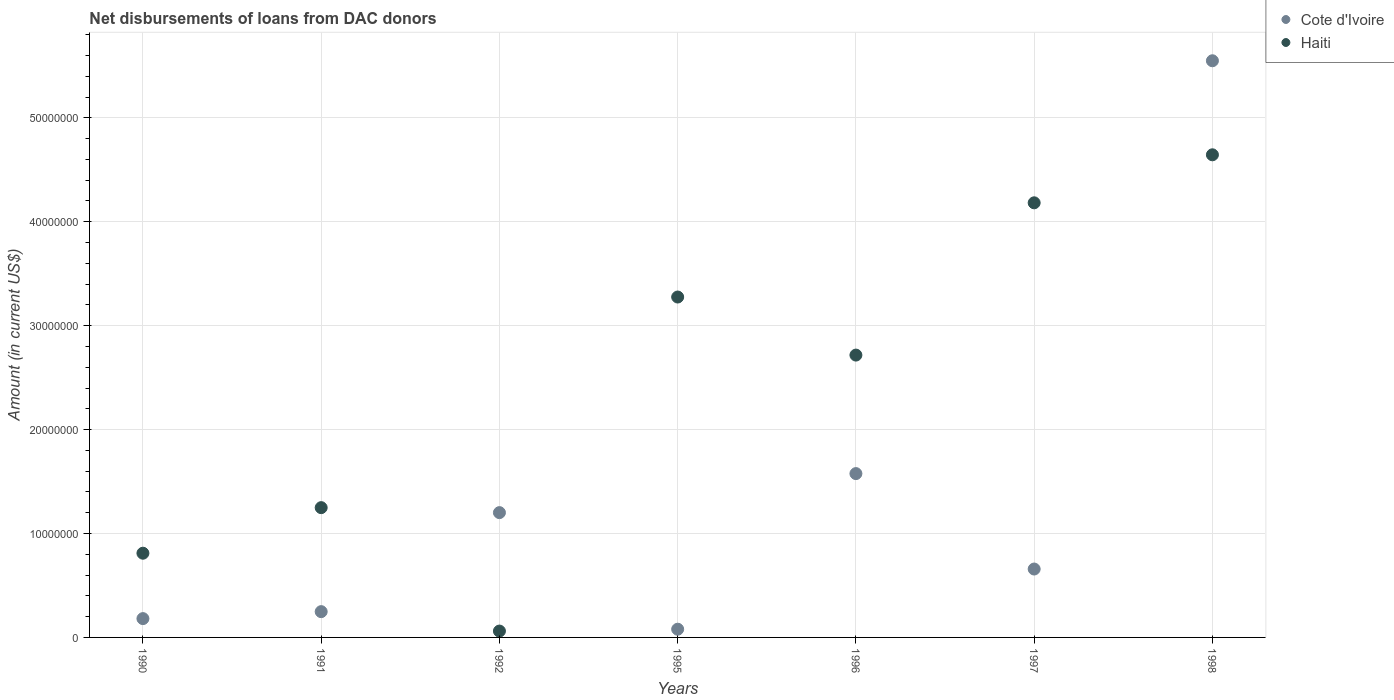How many different coloured dotlines are there?
Provide a succinct answer. 2. Is the number of dotlines equal to the number of legend labels?
Ensure brevity in your answer.  Yes. What is the amount of loans disbursed in Cote d'Ivoire in 1998?
Provide a short and direct response. 5.55e+07. Across all years, what is the maximum amount of loans disbursed in Haiti?
Offer a terse response. 4.64e+07. Across all years, what is the minimum amount of loans disbursed in Haiti?
Your answer should be very brief. 6.12e+05. What is the total amount of loans disbursed in Haiti in the graph?
Your response must be concise. 1.69e+08. What is the difference between the amount of loans disbursed in Cote d'Ivoire in 1995 and that in 1997?
Offer a very short reply. -5.79e+06. What is the difference between the amount of loans disbursed in Haiti in 1995 and the amount of loans disbursed in Cote d'Ivoire in 1997?
Offer a very short reply. 2.62e+07. What is the average amount of loans disbursed in Haiti per year?
Your answer should be very brief. 2.42e+07. In the year 1992, what is the difference between the amount of loans disbursed in Cote d'Ivoire and amount of loans disbursed in Haiti?
Your answer should be compact. 1.14e+07. In how many years, is the amount of loans disbursed in Haiti greater than 24000000 US$?
Keep it short and to the point. 4. What is the ratio of the amount of loans disbursed in Haiti in 1991 to that in 1997?
Provide a succinct answer. 0.3. Is the difference between the amount of loans disbursed in Cote d'Ivoire in 1995 and 1996 greater than the difference between the amount of loans disbursed in Haiti in 1995 and 1996?
Your response must be concise. No. What is the difference between the highest and the second highest amount of loans disbursed in Cote d'Ivoire?
Make the answer very short. 3.97e+07. What is the difference between the highest and the lowest amount of loans disbursed in Haiti?
Offer a terse response. 4.58e+07. In how many years, is the amount of loans disbursed in Haiti greater than the average amount of loans disbursed in Haiti taken over all years?
Provide a short and direct response. 4. Does the amount of loans disbursed in Cote d'Ivoire monotonically increase over the years?
Your answer should be very brief. No. Is the amount of loans disbursed in Cote d'Ivoire strictly greater than the amount of loans disbursed in Haiti over the years?
Keep it short and to the point. No. Is the amount of loans disbursed in Haiti strictly less than the amount of loans disbursed in Cote d'Ivoire over the years?
Your response must be concise. No. What is the difference between two consecutive major ticks on the Y-axis?
Keep it short and to the point. 1.00e+07. Does the graph contain grids?
Your response must be concise. Yes. What is the title of the graph?
Your answer should be compact. Net disbursements of loans from DAC donors. Does "Australia" appear as one of the legend labels in the graph?
Offer a very short reply. No. What is the label or title of the Y-axis?
Provide a succinct answer. Amount (in current US$). What is the Amount (in current US$) in Cote d'Ivoire in 1990?
Give a very brief answer. 1.81e+06. What is the Amount (in current US$) in Haiti in 1990?
Your response must be concise. 8.10e+06. What is the Amount (in current US$) of Cote d'Ivoire in 1991?
Make the answer very short. 2.48e+06. What is the Amount (in current US$) of Haiti in 1991?
Keep it short and to the point. 1.25e+07. What is the Amount (in current US$) in Cote d'Ivoire in 1992?
Your answer should be very brief. 1.20e+07. What is the Amount (in current US$) of Haiti in 1992?
Offer a very short reply. 6.12e+05. What is the Amount (in current US$) in Cote d'Ivoire in 1995?
Offer a terse response. 7.91e+05. What is the Amount (in current US$) of Haiti in 1995?
Your answer should be very brief. 3.28e+07. What is the Amount (in current US$) of Cote d'Ivoire in 1996?
Ensure brevity in your answer.  1.58e+07. What is the Amount (in current US$) in Haiti in 1996?
Offer a terse response. 2.72e+07. What is the Amount (in current US$) of Cote d'Ivoire in 1997?
Ensure brevity in your answer.  6.58e+06. What is the Amount (in current US$) of Haiti in 1997?
Provide a short and direct response. 4.18e+07. What is the Amount (in current US$) in Cote d'Ivoire in 1998?
Your answer should be compact. 5.55e+07. What is the Amount (in current US$) in Haiti in 1998?
Provide a short and direct response. 4.64e+07. Across all years, what is the maximum Amount (in current US$) in Cote d'Ivoire?
Keep it short and to the point. 5.55e+07. Across all years, what is the maximum Amount (in current US$) of Haiti?
Your response must be concise. 4.64e+07. Across all years, what is the minimum Amount (in current US$) of Cote d'Ivoire?
Your response must be concise. 7.91e+05. Across all years, what is the minimum Amount (in current US$) of Haiti?
Provide a short and direct response. 6.12e+05. What is the total Amount (in current US$) in Cote d'Ivoire in the graph?
Offer a very short reply. 9.49e+07. What is the total Amount (in current US$) of Haiti in the graph?
Ensure brevity in your answer.  1.69e+08. What is the difference between the Amount (in current US$) of Cote d'Ivoire in 1990 and that in 1991?
Ensure brevity in your answer.  -6.70e+05. What is the difference between the Amount (in current US$) in Haiti in 1990 and that in 1991?
Provide a short and direct response. -4.38e+06. What is the difference between the Amount (in current US$) in Cote d'Ivoire in 1990 and that in 1992?
Offer a terse response. -1.02e+07. What is the difference between the Amount (in current US$) in Haiti in 1990 and that in 1992?
Provide a short and direct response. 7.49e+06. What is the difference between the Amount (in current US$) of Cote d'Ivoire in 1990 and that in 1995?
Your response must be concise. 1.02e+06. What is the difference between the Amount (in current US$) of Haiti in 1990 and that in 1995?
Give a very brief answer. -2.47e+07. What is the difference between the Amount (in current US$) in Cote d'Ivoire in 1990 and that in 1996?
Offer a very short reply. -1.40e+07. What is the difference between the Amount (in current US$) in Haiti in 1990 and that in 1996?
Offer a very short reply. -1.91e+07. What is the difference between the Amount (in current US$) in Cote d'Ivoire in 1990 and that in 1997?
Offer a terse response. -4.77e+06. What is the difference between the Amount (in current US$) in Haiti in 1990 and that in 1997?
Ensure brevity in your answer.  -3.37e+07. What is the difference between the Amount (in current US$) in Cote d'Ivoire in 1990 and that in 1998?
Give a very brief answer. -5.37e+07. What is the difference between the Amount (in current US$) in Haiti in 1990 and that in 1998?
Offer a terse response. -3.83e+07. What is the difference between the Amount (in current US$) of Cote d'Ivoire in 1991 and that in 1992?
Your answer should be compact. -9.53e+06. What is the difference between the Amount (in current US$) in Haiti in 1991 and that in 1992?
Provide a succinct answer. 1.19e+07. What is the difference between the Amount (in current US$) of Cote d'Ivoire in 1991 and that in 1995?
Provide a short and direct response. 1.69e+06. What is the difference between the Amount (in current US$) in Haiti in 1991 and that in 1995?
Your answer should be very brief. -2.03e+07. What is the difference between the Amount (in current US$) of Cote d'Ivoire in 1991 and that in 1996?
Ensure brevity in your answer.  -1.33e+07. What is the difference between the Amount (in current US$) of Haiti in 1991 and that in 1996?
Your response must be concise. -1.47e+07. What is the difference between the Amount (in current US$) of Cote d'Ivoire in 1991 and that in 1997?
Offer a very short reply. -4.10e+06. What is the difference between the Amount (in current US$) in Haiti in 1991 and that in 1997?
Make the answer very short. -2.93e+07. What is the difference between the Amount (in current US$) of Cote d'Ivoire in 1991 and that in 1998?
Ensure brevity in your answer.  -5.30e+07. What is the difference between the Amount (in current US$) of Haiti in 1991 and that in 1998?
Your response must be concise. -3.40e+07. What is the difference between the Amount (in current US$) in Cote d'Ivoire in 1992 and that in 1995?
Your answer should be compact. 1.12e+07. What is the difference between the Amount (in current US$) in Haiti in 1992 and that in 1995?
Your response must be concise. -3.21e+07. What is the difference between the Amount (in current US$) in Cote d'Ivoire in 1992 and that in 1996?
Give a very brief answer. -3.76e+06. What is the difference between the Amount (in current US$) of Haiti in 1992 and that in 1996?
Offer a terse response. -2.66e+07. What is the difference between the Amount (in current US$) of Cote d'Ivoire in 1992 and that in 1997?
Ensure brevity in your answer.  5.43e+06. What is the difference between the Amount (in current US$) of Haiti in 1992 and that in 1997?
Provide a succinct answer. -4.12e+07. What is the difference between the Amount (in current US$) of Cote d'Ivoire in 1992 and that in 1998?
Offer a terse response. -4.35e+07. What is the difference between the Amount (in current US$) of Haiti in 1992 and that in 1998?
Offer a terse response. -4.58e+07. What is the difference between the Amount (in current US$) of Cote d'Ivoire in 1995 and that in 1996?
Make the answer very short. -1.50e+07. What is the difference between the Amount (in current US$) in Haiti in 1995 and that in 1996?
Your response must be concise. 5.59e+06. What is the difference between the Amount (in current US$) of Cote d'Ivoire in 1995 and that in 1997?
Make the answer very short. -5.79e+06. What is the difference between the Amount (in current US$) in Haiti in 1995 and that in 1997?
Offer a terse response. -9.07e+06. What is the difference between the Amount (in current US$) of Cote d'Ivoire in 1995 and that in 1998?
Provide a short and direct response. -5.47e+07. What is the difference between the Amount (in current US$) of Haiti in 1995 and that in 1998?
Make the answer very short. -1.37e+07. What is the difference between the Amount (in current US$) of Cote d'Ivoire in 1996 and that in 1997?
Ensure brevity in your answer.  9.18e+06. What is the difference between the Amount (in current US$) in Haiti in 1996 and that in 1997?
Offer a terse response. -1.47e+07. What is the difference between the Amount (in current US$) in Cote d'Ivoire in 1996 and that in 1998?
Offer a very short reply. -3.97e+07. What is the difference between the Amount (in current US$) in Haiti in 1996 and that in 1998?
Your answer should be compact. -1.93e+07. What is the difference between the Amount (in current US$) in Cote d'Ivoire in 1997 and that in 1998?
Your answer should be compact. -4.89e+07. What is the difference between the Amount (in current US$) of Haiti in 1997 and that in 1998?
Ensure brevity in your answer.  -4.62e+06. What is the difference between the Amount (in current US$) of Cote d'Ivoire in 1990 and the Amount (in current US$) of Haiti in 1991?
Make the answer very short. -1.07e+07. What is the difference between the Amount (in current US$) of Cote d'Ivoire in 1990 and the Amount (in current US$) of Haiti in 1992?
Offer a terse response. 1.20e+06. What is the difference between the Amount (in current US$) in Cote d'Ivoire in 1990 and the Amount (in current US$) in Haiti in 1995?
Your response must be concise. -3.09e+07. What is the difference between the Amount (in current US$) of Cote d'Ivoire in 1990 and the Amount (in current US$) of Haiti in 1996?
Offer a terse response. -2.54e+07. What is the difference between the Amount (in current US$) in Cote d'Ivoire in 1990 and the Amount (in current US$) in Haiti in 1997?
Offer a very short reply. -4.00e+07. What is the difference between the Amount (in current US$) in Cote d'Ivoire in 1990 and the Amount (in current US$) in Haiti in 1998?
Keep it short and to the point. -4.46e+07. What is the difference between the Amount (in current US$) in Cote d'Ivoire in 1991 and the Amount (in current US$) in Haiti in 1992?
Provide a succinct answer. 1.87e+06. What is the difference between the Amount (in current US$) in Cote d'Ivoire in 1991 and the Amount (in current US$) in Haiti in 1995?
Keep it short and to the point. -3.03e+07. What is the difference between the Amount (in current US$) of Cote d'Ivoire in 1991 and the Amount (in current US$) of Haiti in 1996?
Provide a succinct answer. -2.47e+07. What is the difference between the Amount (in current US$) of Cote d'Ivoire in 1991 and the Amount (in current US$) of Haiti in 1997?
Your answer should be compact. -3.93e+07. What is the difference between the Amount (in current US$) of Cote d'Ivoire in 1991 and the Amount (in current US$) of Haiti in 1998?
Provide a short and direct response. -4.40e+07. What is the difference between the Amount (in current US$) in Cote d'Ivoire in 1992 and the Amount (in current US$) in Haiti in 1995?
Provide a succinct answer. -2.07e+07. What is the difference between the Amount (in current US$) of Cote d'Ivoire in 1992 and the Amount (in current US$) of Haiti in 1996?
Make the answer very short. -1.52e+07. What is the difference between the Amount (in current US$) of Cote d'Ivoire in 1992 and the Amount (in current US$) of Haiti in 1997?
Your answer should be compact. -2.98e+07. What is the difference between the Amount (in current US$) in Cote d'Ivoire in 1992 and the Amount (in current US$) in Haiti in 1998?
Provide a short and direct response. -3.44e+07. What is the difference between the Amount (in current US$) of Cote d'Ivoire in 1995 and the Amount (in current US$) of Haiti in 1996?
Your answer should be compact. -2.64e+07. What is the difference between the Amount (in current US$) in Cote d'Ivoire in 1995 and the Amount (in current US$) in Haiti in 1997?
Make the answer very short. -4.10e+07. What is the difference between the Amount (in current US$) in Cote d'Ivoire in 1995 and the Amount (in current US$) in Haiti in 1998?
Offer a terse response. -4.57e+07. What is the difference between the Amount (in current US$) of Cote d'Ivoire in 1996 and the Amount (in current US$) of Haiti in 1997?
Ensure brevity in your answer.  -2.61e+07. What is the difference between the Amount (in current US$) of Cote d'Ivoire in 1996 and the Amount (in current US$) of Haiti in 1998?
Your answer should be very brief. -3.07e+07. What is the difference between the Amount (in current US$) of Cote d'Ivoire in 1997 and the Amount (in current US$) of Haiti in 1998?
Offer a very short reply. -3.99e+07. What is the average Amount (in current US$) of Cote d'Ivoire per year?
Your answer should be very brief. 1.36e+07. What is the average Amount (in current US$) in Haiti per year?
Offer a very short reply. 2.42e+07. In the year 1990, what is the difference between the Amount (in current US$) of Cote d'Ivoire and Amount (in current US$) of Haiti?
Keep it short and to the point. -6.29e+06. In the year 1991, what is the difference between the Amount (in current US$) in Cote d'Ivoire and Amount (in current US$) in Haiti?
Your answer should be very brief. -1.00e+07. In the year 1992, what is the difference between the Amount (in current US$) in Cote d'Ivoire and Amount (in current US$) in Haiti?
Give a very brief answer. 1.14e+07. In the year 1995, what is the difference between the Amount (in current US$) of Cote d'Ivoire and Amount (in current US$) of Haiti?
Keep it short and to the point. -3.20e+07. In the year 1996, what is the difference between the Amount (in current US$) of Cote d'Ivoire and Amount (in current US$) of Haiti?
Keep it short and to the point. -1.14e+07. In the year 1997, what is the difference between the Amount (in current US$) of Cote d'Ivoire and Amount (in current US$) of Haiti?
Your response must be concise. -3.52e+07. In the year 1998, what is the difference between the Amount (in current US$) in Cote d'Ivoire and Amount (in current US$) in Haiti?
Your answer should be compact. 9.05e+06. What is the ratio of the Amount (in current US$) of Cote d'Ivoire in 1990 to that in 1991?
Your answer should be very brief. 0.73. What is the ratio of the Amount (in current US$) of Haiti in 1990 to that in 1991?
Your response must be concise. 0.65. What is the ratio of the Amount (in current US$) of Cote d'Ivoire in 1990 to that in 1992?
Offer a terse response. 0.15. What is the ratio of the Amount (in current US$) of Haiti in 1990 to that in 1992?
Keep it short and to the point. 13.24. What is the ratio of the Amount (in current US$) of Cote d'Ivoire in 1990 to that in 1995?
Provide a succinct answer. 2.29. What is the ratio of the Amount (in current US$) of Haiti in 1990 to that in 1995?
Your response must be concise. 0.25. What is the ratio of the Amount (in current US$) in Cote d'Ivoire in 1990 to that in 1996?
Offer a terse response. 0.11. What is the ratio of the Amount (in current US$) in Haiti in 1990 to that in 1996?
Your answer should be very brief. 0.3. What is the ratio of the Amount (in current US$) of Cote d'Ivoire in 1990 to that in 1997?
Offer a terse response. 0.28. What is the ratio of the Amount (in current US$) in Haiti in 1990 to that in 1997?
Make the answer very short. 0.19. What is the ratio of the Amount (in current US$) of Cote d'Ivoire in 1990 to that in 1998?
Your answer should be compact. 0.03. What is the ratio of the Amount (in current US$) of Haiti in 1990 to that in 1998?
Keep it short and to the point. 0.17. What is the ratio of the Amount (in current US$) in Cote d'Ivoire in 1991 to that in 1992?
Keep it short and to the point. 0.21. What is the ratio of the Amount (in current US$) of Haiti in 1991 to that in 1992?
Provide a short and direct response. 20.41. What is the ratio of the Amount (in current US$) of Cote d'Ivoire in 1991 to that in 1995?
Ensure brevity in your answer.  3.14. What is the ratio of the Amount (in current US$) of Haiti in 1991 to that in 1995?
Provide a succinct answer. 0.38. What is the ratio of the Amount (in current US$) of Cote d'Ivoire in 1991 to that in 1996?
Offer a terse response. 0.16. What is the ratio of the Amount (in current US$) in Haiti in 1991 to that in 1996?
Make the answer very short. 0.46. What is the ratio of the Amount (in current US$) in Cote d'Ivoire in 1991 to that in 1997?
Make the answer very short. 0.38. What is the ratio of the Amount (in current US$) of Haiti in 1991 to that in 1997?
Offer a terse response. 0.3. What is the ratio of the Amount (in current US$) in Cote d'Ivoire in 1991 to that in 1998?
Provide a succinct answer. 0.04. What is the ratio of the Amount (in current US$) of Haiti in 1991 to that in 1998?
Give a very brief answer. 0.27. What is the ratio of the Amount (in current US$) in Cote d'Ivoire in 1992 to that in 1995?
Ensure brevity in your answer.  15.18. What is the ratio of the Amount (in current US$) in Haiti in 1992 to that in 1995?
Give a very brief answer. 0.02. What is the ratio of the Amount (in current US$) in Cote d'Ivoire in 1992 to that in 1996?
Offer a very short reply. 0.76. What is the ratio of the Amount (in current US$) in Haiti in 1992 to that in 1996?
Ensure brevity in your answer.  0.02. What is the ratio of the Amount (in current US$) in Cote d'Ivoire in 1992 to that in 1997?
Give a very brief answer. 1.82. What is the ratio of the Amount (in current US$) of Haiti in 1992 to that in 1997?
Your response must be concise. 0.01. What is the ratio of the Amount (in current US$) of Cote d'Ivoire in 1992 to that in 1998?
Provide a short and direct response. 0.22. What is the ratio of the Amount (in current US$) of Haiti in 1992 to that in 1998?
Offer a terse response. 0.01. What is the ratio of the Amount (in current US$) of Cote d'Ivoire in 1995 to that in 1996?
Offer a very short reply. 0.05. What is the ratio of the Amount (in current US$) in Haiti in 1995 to that in 1996?
Give a very brief answer. 1.21. What is the ratio of the Amount (in current US$) of Cote d'Ivoire in 1995 to that in 1997?
Offer a very short reply. 0.12. What is the ratio of the Amount (in current US$) of Haiti in 1995 to that in 1997?
Your answer should be very brief. 0.78. What is the ratio of the Amount (in current US$) in Cote d'Ivoire in 1995 to that in 1998?
Offer a terse response. 0.01. What is the ratio of the Amount (in current US$) in Haiti in 1995 to that in 1998?
Ensure brevity in your answer.  0.71. What is the ratio of the Amount (in current US$) in Cote d'Ivoire in 1996 to that in 1997?
Your answer should be compact. 2.4. What is the ratio of the Amount (in current US$) of Haiti in 1996 to that in 1997?
Your response must be concise. 0.65. What is the ratio of the Amount (in current US$) in Cote d'Ivoire in 1996 to that in 1998?
Your response must be concise. 0.28. What is the ratio of the Amount (in current US$) of Haiti in 1996 to that in 1998?
Your response must be concise. 0.58. What is the ratio of the Amount (in current US$) of Cote d'Ivoire in 1997 to that in 1998?
Ensure brevity in your answer.  0.12. What is the ratio of the Amount (in current US$) of Haiti in 1997 to that in 1998?
Provide a succinct answer. 0.9. What is the difference between the highest and the second highest Amount (in current US$) of Cote d'Ivoire?
Offer a very short reply. 3.97e+07. What is the difference between the highest and the second highest Amount (in current US$) in Haiti?
Give a very brief answer. 4.62e+06. What is the difference between the highest and the lowest Amount (in current US$) of Cote d'Ivoire?
Keep it short and to the point. 5.47e+07. What is the difference between the highest and the lowest Amount (in current US$) in Haiti?
Your response must be concise. 4.58e+07. 